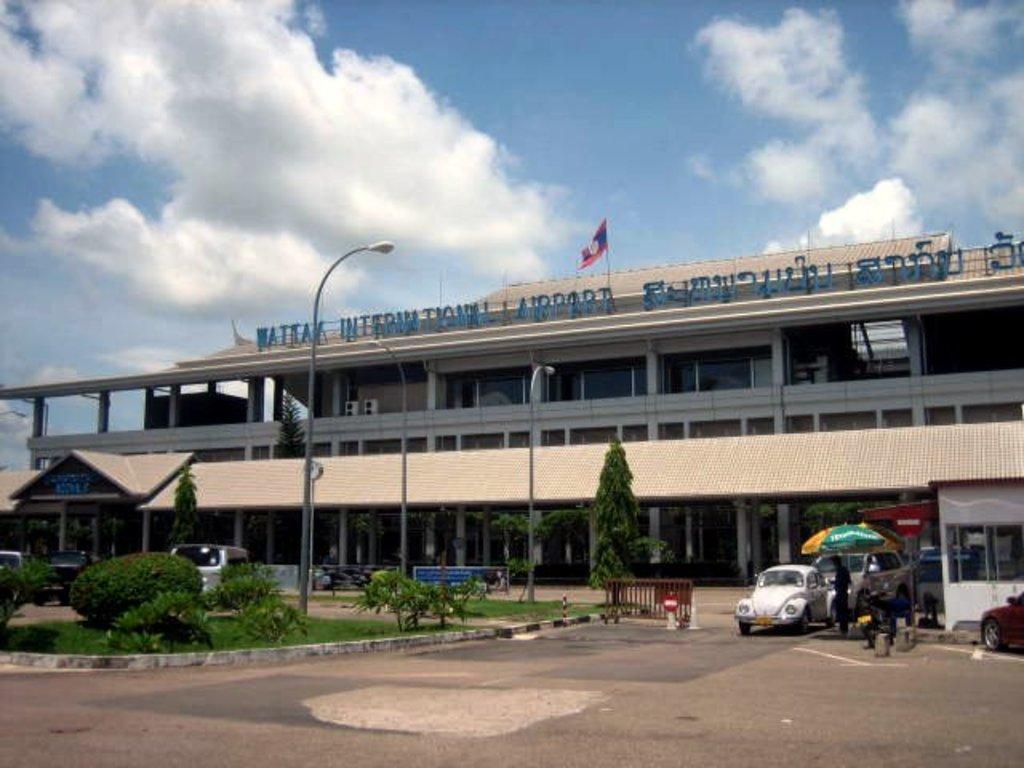In one or two sentences, can you explain what this image depicts? As we can see in the image there are buildings, trees, plants, grass, street lamps, cars, few people here and there and a flag. On the top there is sky and clouds. 